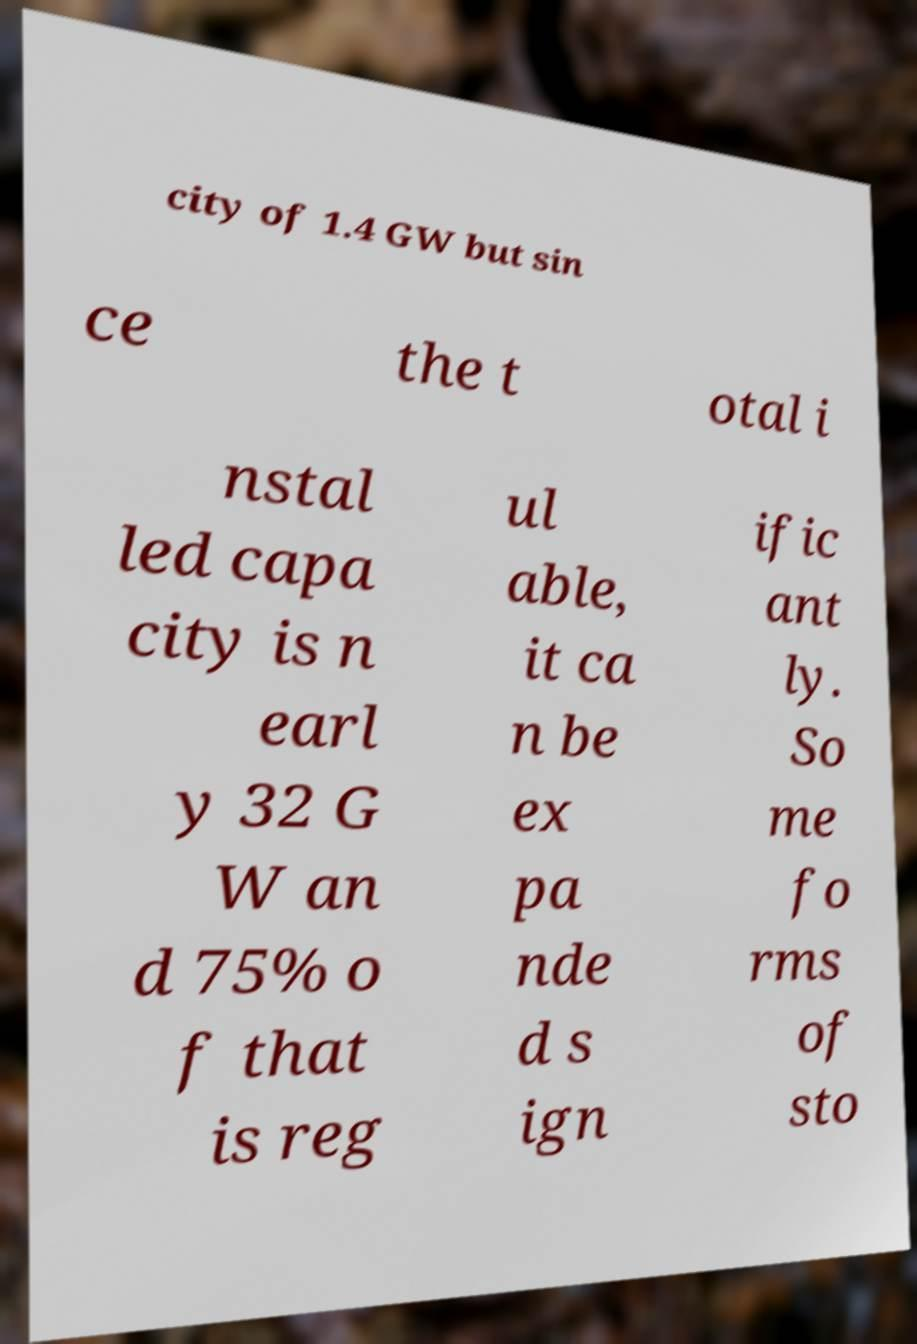Please identify and transcribe the text found in this image. city of 1.4 GW but sin ce the t otal i nstal led capa city is n earl y 32 G W an d 75% o f that is reg ul able, it ca n be ex pa nde d s ign ific ant ly. So me fo rms of sto 